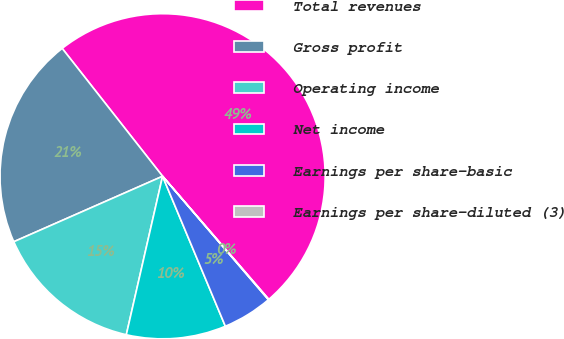Convert chart. <chart><loc_0><loc_0><loc_500><loc_500><pie_chart><fcel>Total revenues<fcel>Gross profit<fcel>Operating income<fcel>Net income<fcel>Earnings per share-basic<fcel>Earnings per share-diluted (3)<nl><fcel>49.26%<fcel>21.0%<fcel>14.82%<fcel>9.89%<fcel>4.97%<fcel>0.05%<nl></chart> 